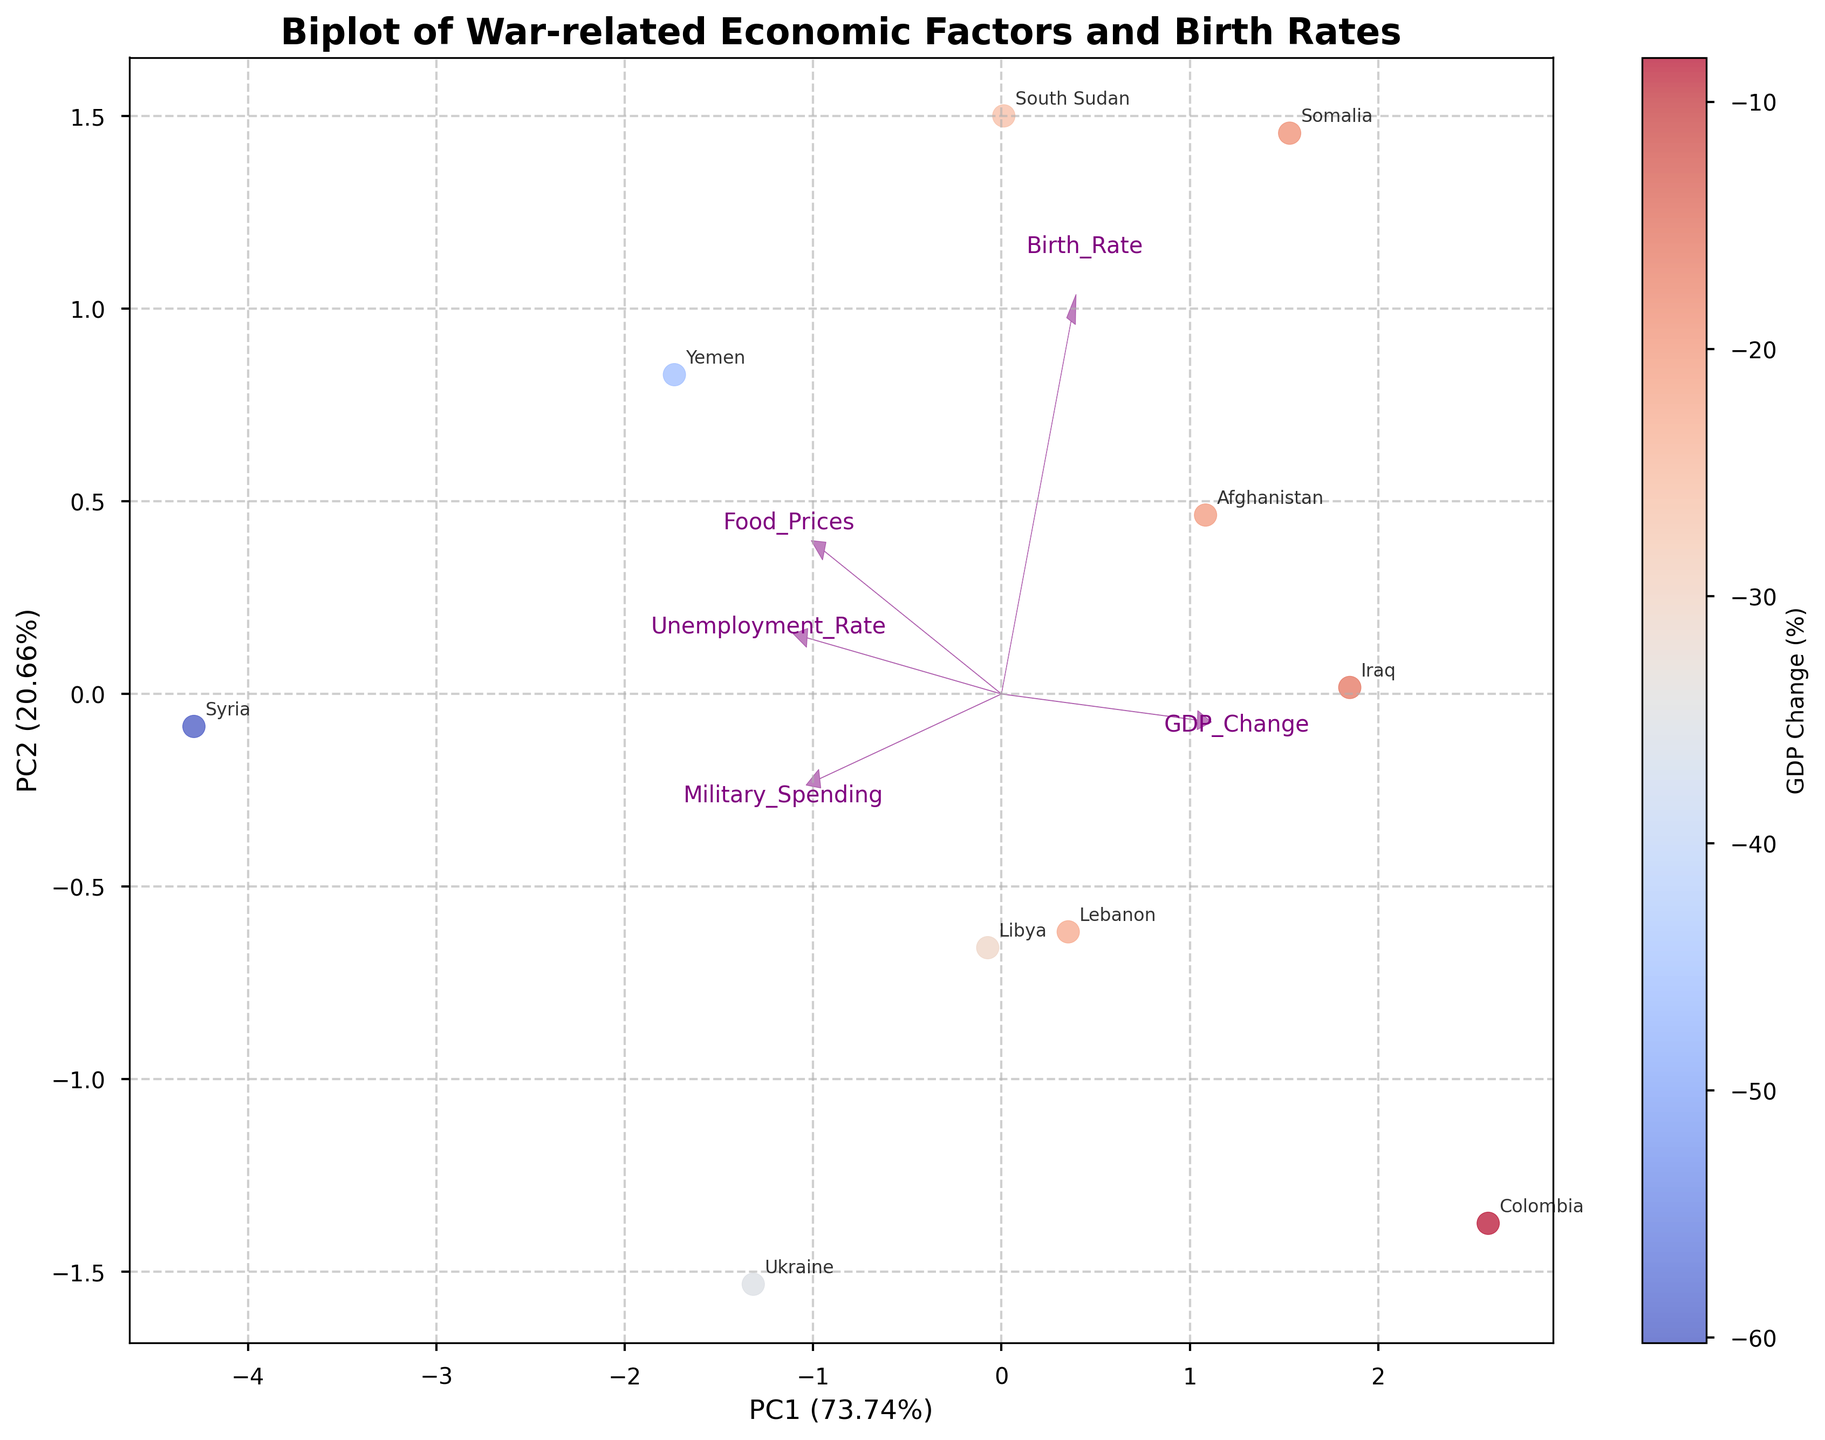What does the title of the plot indicate? The title "Biplot of War-related Economic Factors and Birth Rates" suggests that the plot visualizes the relationships between economic factors influenced by war and birth rates in different regions.
Answer: The plot shows associations between war-related economic factors and birth rates Which country has the highest unemployment rate based on the biplot? The biplot labels show that Syria has the highest unemployment rate.
Answer: Syria How is the food prices variable represented in the biplot? Food prices are represented by one of the purple arrows originating from the center, which shows the direction and magnitude of food prices' impact along the principal components.
Answer: By a purple arrow Which country appears closest to the origin in the biplot? The country closest to the origin is represented by Colombia, indicating it has more moderate values across the economic factors and birth rates.
Answer: Colombia What percentage of the variance is explained by the first principal component (PC1)? The x-axis label indicates PC1 explains a certain percentage of the variance. In this case, it's recorded as a number in the format "XX.XX%".
Answer: Percentage value on the x-axis label Compare the birth rates of Somalia and Afghanistan according to the biplot. Somalia and Afghanistan are represented at different points in the biplot. Somalia is positioned further along the birth rate vector indicating it has a higher birth rate compared to Afghanistan.
Answer: Somalia has a higher birth rate than Afghanistan How does GDP change correlate with the principal components in the biplot? The color gradient in the biplot correlates GDP change with the principal components, indicating different GDP change intensities across the positions in the plot.
Answer: Through the color gradient Identify which economic factor has the most significant positive loading on the first principal component. The vector that is the longest along the PC1 axis represents the economic factor with the most significant positive loading.
Answer: The factor associated with the longest arrow on the x-axis Based on the color gradient, which country has experienced the most significant negative GDP change? The biplot uses a coolwarm colormap, and the most extreme negative GDP change is represented by the darkest blue point.
Answer: Syria What are the coordinates of South Sudan on the biplot? Examine the position of South Sudan's label in relation to the PC1 and PC2 axes for its exact coordinates.
Answer: Coordinate values on the plot 